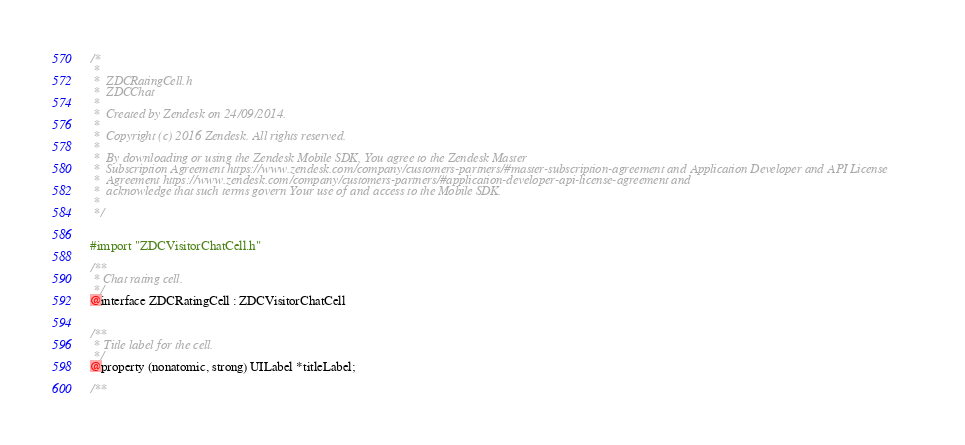Convert code to text. <code><loc_0><loc_0><loc_500><loc_500><_C_>/*
 *
 *  ZDCRatingCell.h
 *  ZDCChat
 *
 *  Created by Zendesk on 24/09/2014.
 *
 *  Copyright (c) 2016 Zendesk. All rights reserved.
 *
 *  By downloading or using the Zendesk Mobile SDK, You agree to the Zendesk Master
 *  Subscription Agreement https://www.zendesk.com/company/customers-partners/#master-subscription-agreement and Application Developer and API License
 *  Agreement https://www.zendesk.com/company/customers-partners/#application-developer-api-license-agreement and
 *  acknowledge that such terms govern Your use of and access to the Mobile SDK.
 *
 */


#import "ZDCVisitorChatCell.h"

/**
 * Chat rating cell.
 */
@interface ZDCRatingCell : ZDCVisitorChatCell


/**
 * Title label for the cell.
 */
@property (nonatomic, strong) UILabel *titleLabel;

/**</code> 